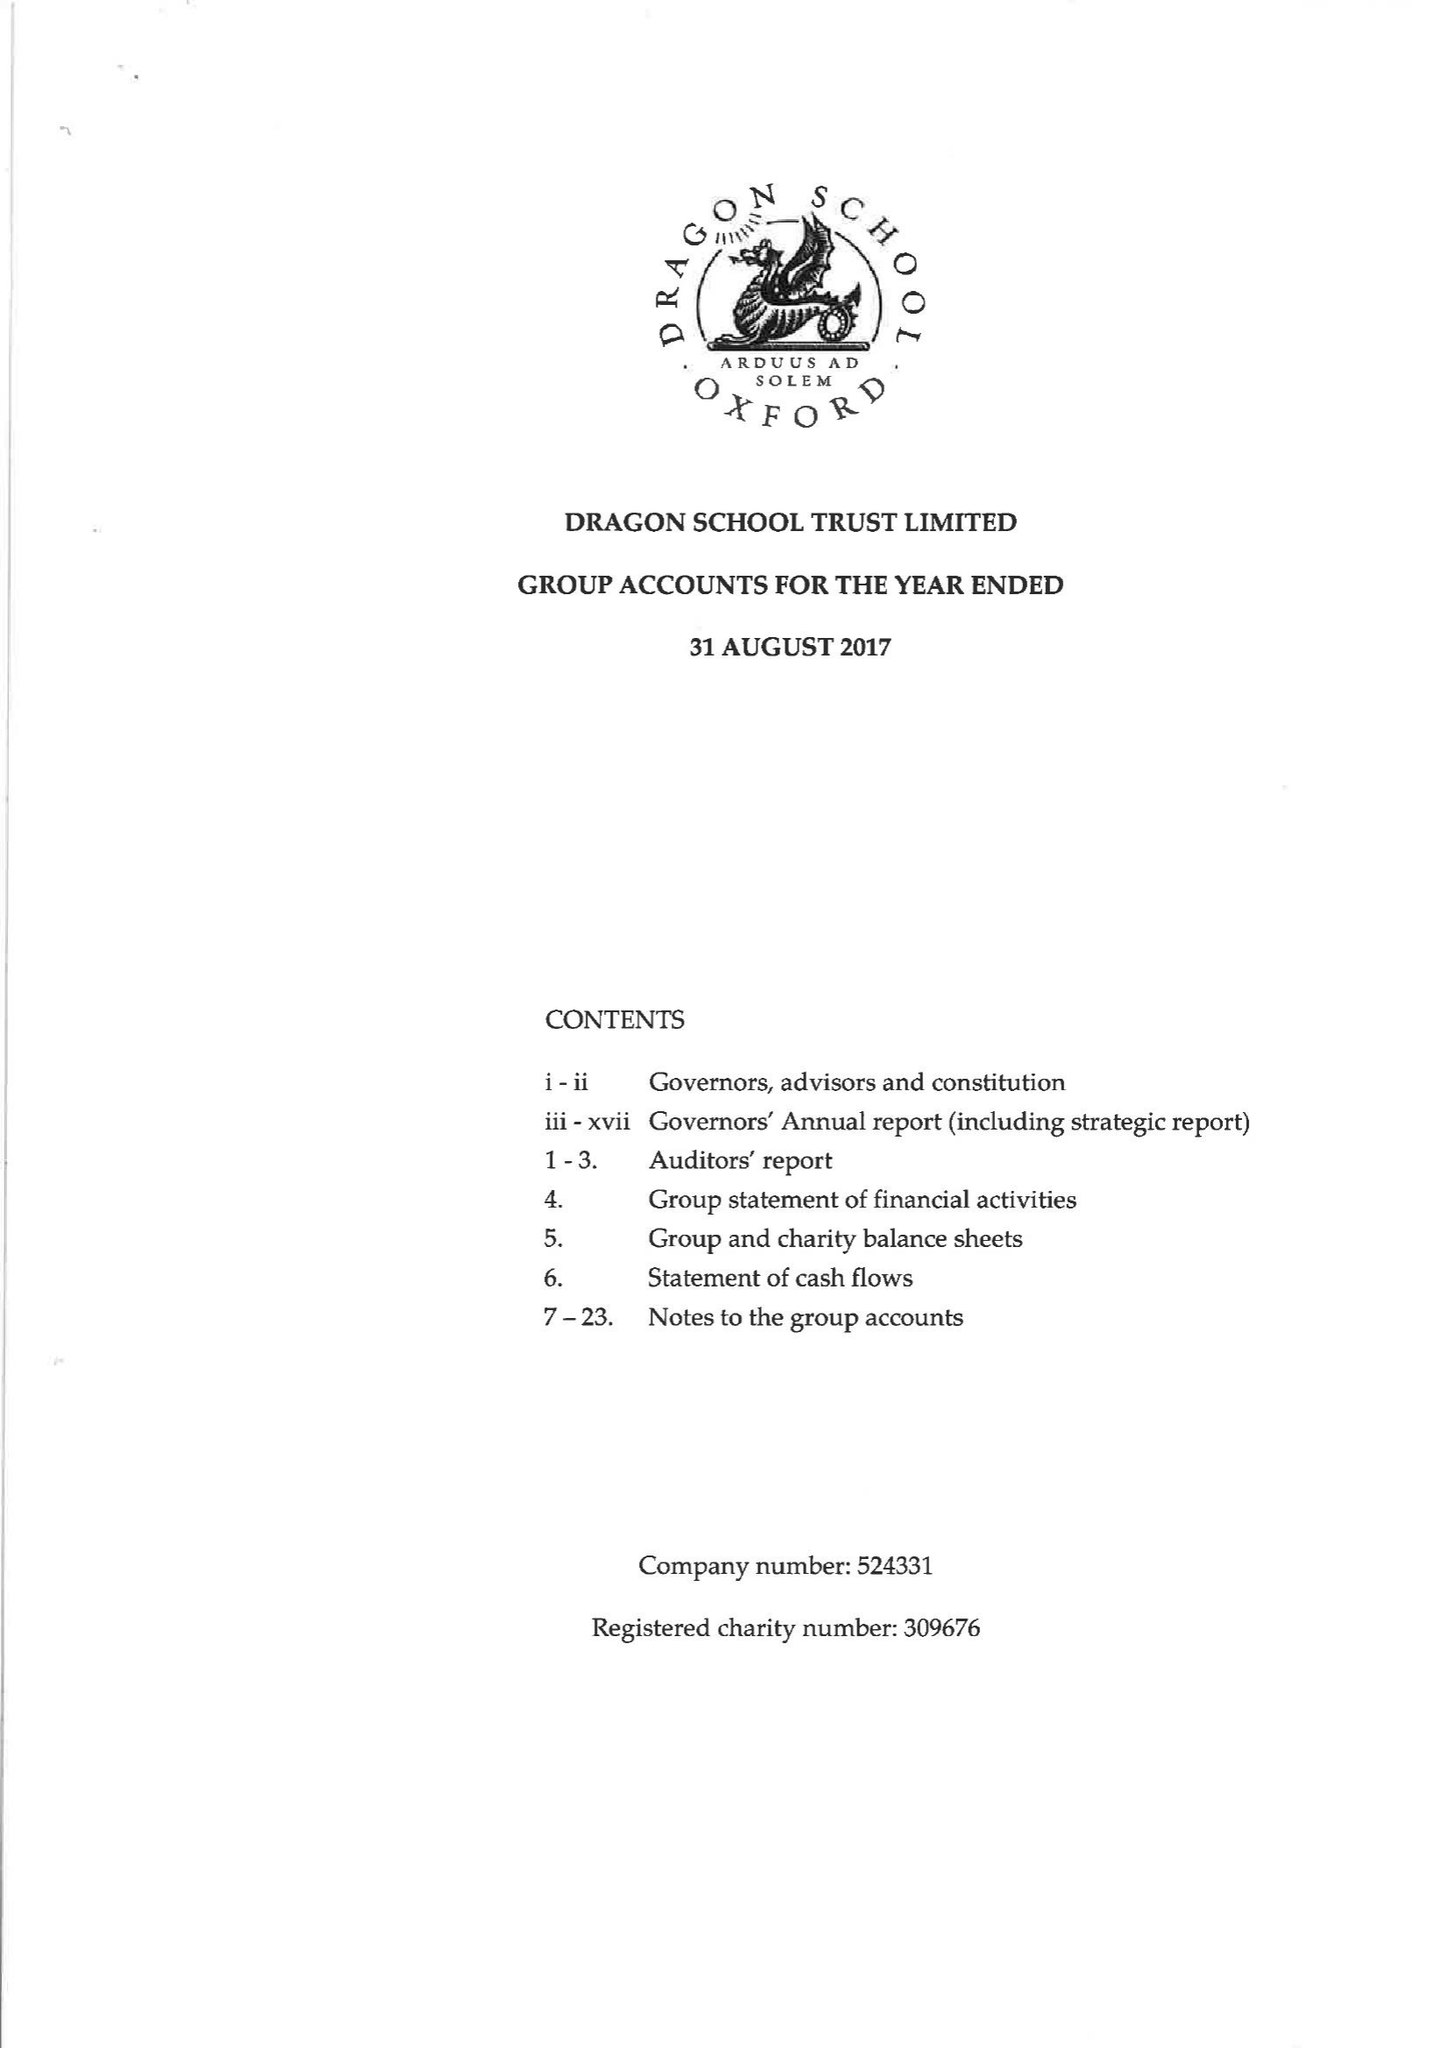What is the value for the spending_annually_in_british_pounds?
Answer the question using a single word or phrase. 17467000.00 